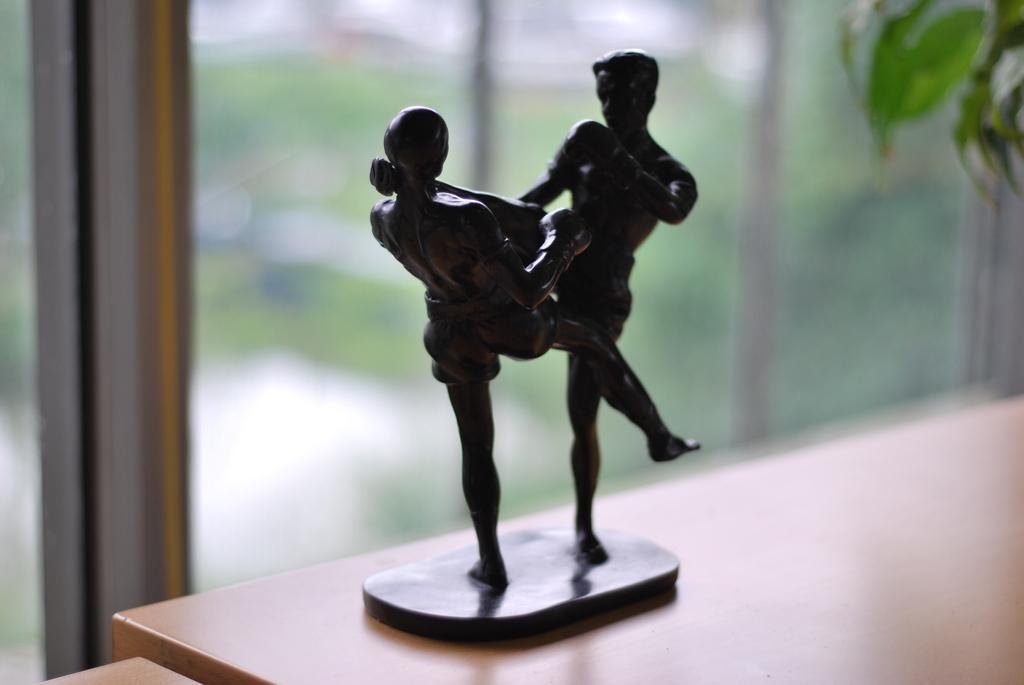What is the main subject in the image? There is a statue in the image. What does the statue resemble? The statue resembles a human. How many people are present in the image? There are two people in the image. Where is the statue placed? The statue is placed on a surface. Can you describe the image in the background? The image in the background is blurred. What type of zephyr is present in the image? There is no zephyr present in the image. In which direction is the statue facing in the image? The provided facts do not mention the direction the statue is facing, so we cannot definitively answer this question. 